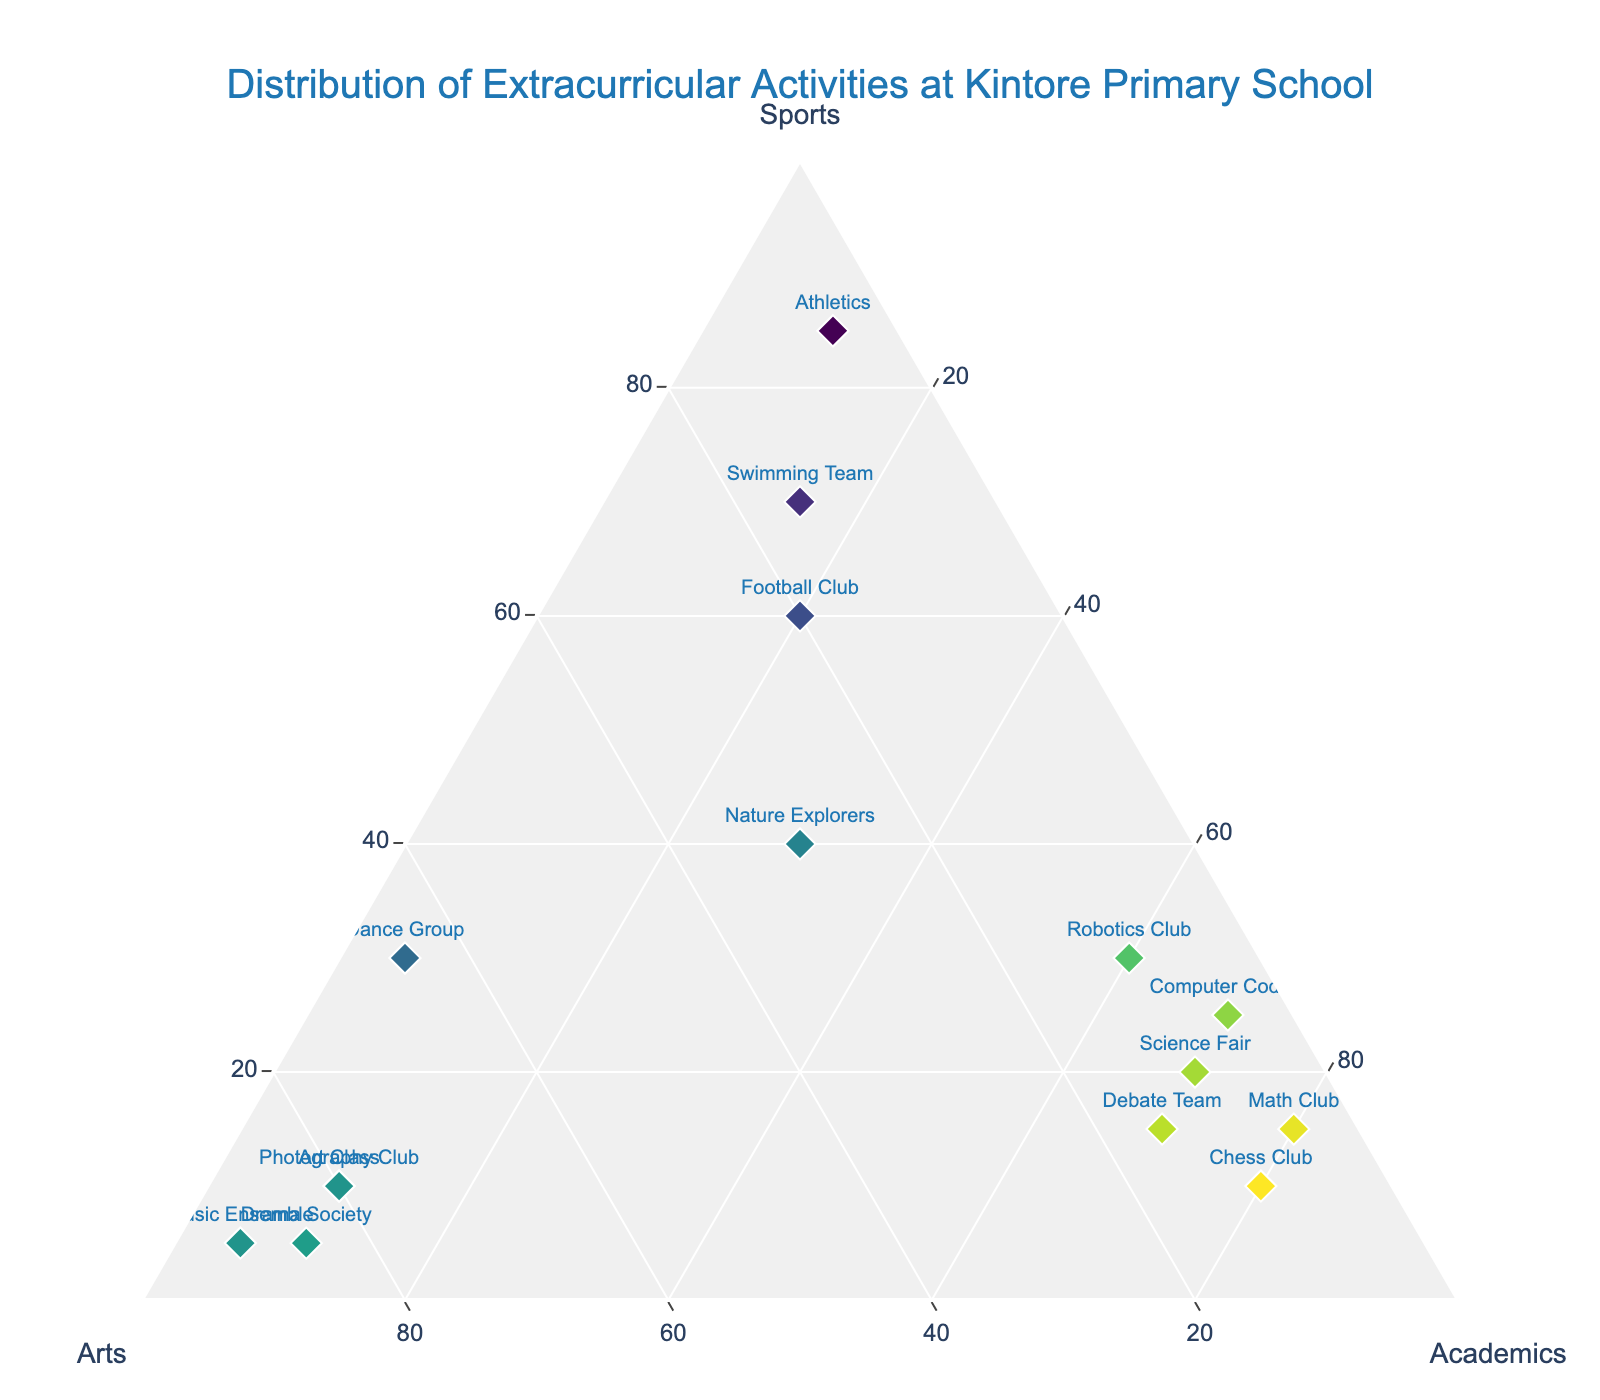How many activities are represented in the plot? Count the number of unique activities depicted as markers on the ternary plot.
Answer: 15 What is the title of the plot? The title is given at the top of the plot as specified in the layout.
Answer: Distribution of Extracurricular Activities at Kintore Primary School Which activity is most heavily skewed towards "Sports"? Look for the marker that is closest to the "Sports" vertex of the ternary plot.
Answer: Athletics How many activities have their highest composition in "Academics"? Identify the markers where the “Academics” value is the highest among the three categories (Sports, Arts, Academics).
Answer: 6 Which activity has balanced contributions among Sports, Arts, and Academics? Identify the marker that lies closest to the center of the ternary plot, indicating relatively equal values for all three categories.
Answer: Nature Explorers Are there more activities skewed heavily towards "Arts" or "Academics"? Compare the number of markers closest to the "Arts" vertex with those closest to the "Academics" vertex.
Answer: Arts Which activity has the highest "Arts" value? Look for the marker closest to the "Arts" vertex and check its label.
Answer: Music Ensemble Which two activities have the same ratio of Sports, Arts, and Academics? Check if any two markers align perfectly on the same radial line from the center, having the same ratio of the three categories.
Answer: Debate Team and Science Fair What's the combined percentage of "Sports" in Football Club and Swimming Team? Add the "Sports" percentage values of Football Club and Swimming Team.
Answer: 130 Which has a higher proportion of Sports, Math Club or Chess Club? Compare the "Sports" percentages for Math Club and Chess Club.
Answer: Math Club 